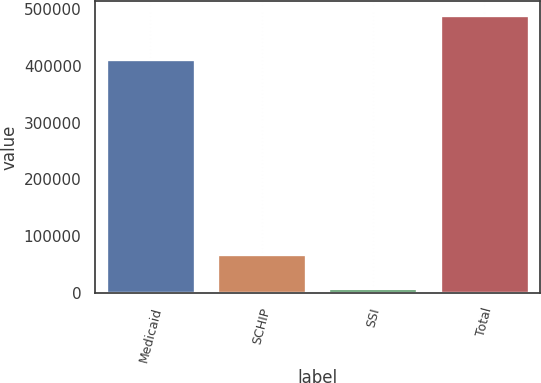Convert chart to OTSL. <chart><loc_0><loc_0><loc_500><loc_500><bar_chart><fcel>Medicaid<fcel>SCHIP<fcel>SSI<fcel>Total<nl><fcel>411800<fcel>68400<fcel>9400<fcel>489600<nl></chart> 